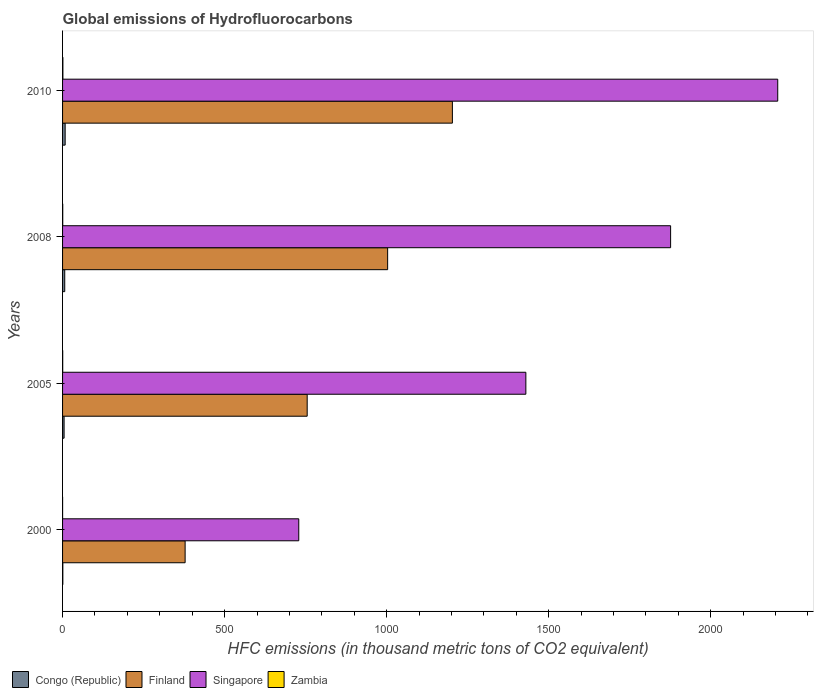How many different coloured bars are there?
Keep it short and to the point. 4. How many groups of bars are there?
Your answer should be very brief. 4. How many bars are there on the 2nd tick from the top?
Keep it short and to the point. 4. How many bars are there on the 1st tick from the bottom?
Your response must be concise. 4. What is the global emissions of Hydrofluorocarbons in Singapore in 2008?
Give a very brief answer. 1876.4. Across all years, what is the maximum global emissions of Hydrofluorocarbons in Singapore?
Keep it short and to the point. 2207. In which year was the global emissions of Hydrofluorocarbons in Zambia maximum?
Provide a short and direct response. 2010. What is the total global emissions of Hydrofluorocarbons in Singapore in the graph?
Your answer should be very brief. 6242. What is the difference between the global emissions of Hydrofluorocarbons in Singapore in 2008 and that in 2010?
Provide a short and direct response. -330.6. What is the difference between the global emissions of Hydrofluorocarbons in Congo (Republic) in 2000 and the global emissions of Hydrofluorocarbons in Zambia in 2008?
Your response must be concise. 0.3. What is the average global emissions of Hydrofluorocarbons in Zambia per year?
Your response must be concise. 0.5. In the year 2005, what is the difference between the global emissions of Hydrofluorocarbons in Finland and global emissions of Hydrofluorocarbons in Zambia?
Keep it short and to the point. 754.5. Is the difference between the global emissions of Hydrofluorocarbons in Finland in 2005 and 2010 greater than the difference between the global emissions of Hydrofluorocarbons in Zambia in 2005 and 2010?
Keep it short and to the point. No. What is the difference between the highest and the second highest global emissions of Hydrofluorocarbons in Congo (Republic)?
Ensure brevity in your answer.  1.3. What is the difference between the highest and the lowest global emissions of Hydrofluorocarbons in Finland?
Provide a short and direct response. 824.8. What does the 1st bar from the top in 2008 represents?
Keep it short and to the point. Zambia. What does the 4th bar from the bottom in 2000 represents?
Keep it short and to the point. Zambia. Are all the bars in the graph horizontal?
Make the answer very short. Yes. What is the difference between two consecutive major ticks on the X-axis?
Your answer should be very brief. 500. Does the graph contain grids?
Keep it short and to the point. No. Where does the legend appear in the graph?
Your answer should be compact. Bottom left. How many legend labels are there?
Offer a very short reply. 4. How are the legend labels stacked?
Make the answer very short. Horizontal. What is the title of the graph?
Provide a succinct answer. Global emissions of Hydrofluorocarbons. Does "Mozambique" appear as one of the legend labels in the graph?
Offer a terse response. No. What is the label or title of the X-axis?
Your answer should be compact. HFC emissions (in thousand metric tons of CO2 equivalent). What is the HFC emissions (in thousand metric tons of CO2 equivalent) in Finland in 2000?
Offer a very short reply. 378.2. What is the HFC emissions (in thousand metric tons of CO2 equivalent) in Singapore in 2000?
Keep it short and to the point. 728.9. What is the HFC emissions (in thousand metric tons of CO2 equivalent) of Zambia in 2000?
Your answer should be compact. 0.1. What is the HFC emissions (in thousand metric tons of CO2 equivalent) of Finland in 2005?
Give a very brief answer. 754.9. What is the HFC emissions (in thousand metric tons of CO2 equivalent) of Singapore in 2005?
Your answer should be very brief. 1429.7. What is the HFC emissions (in thousand metric tons of CO2 equivalent) in Finland in 2008?
Give a very brief answer. 1003.2. What is the HFC emissions (in thousand metric tons of CO2 equivalent) in Singapore in 2008?
Give a very brief answer. 1876.4. What is the HFC emissions (in thousand metric tons of CO2 equivalent) of Finland in 2010?
Make the answer very short. 1203. What is the HFC emissions (in thousand metric tons of CO2 equivalent) in Singapore in 2010?
Offer a very short reply. 2207. What is the HFC emissions (in thousand metric tons of CO2 equivalent) of Zambia in 2010?
Your response must be concise. 1. Across all years, what is the maximum HFC emissions (in thousand metric tons of CO2 equivalent) in Congo (Republic)?
Provide a succinct answer. 8. Across all years, what is the maximum HFC emissions (in thousand metric tons of CO2 equivalent) of Finland?
Your response must be concise. 1203. Across all years, what is the maximum HFC emissions (in thousand metric tons of CO2 equivalent) of Singapore?
Provide a short and direct response. 2207. Across all years, what is the maximum HFC emissions (in thousand metric tons of CO2 equivalent) in Zambia?
Your answer should be compact. 1. Across all years, what is the minimum HFC emissions (in thousand metric tons of CO2 equivalent) of Finland?
Provide a short and direct response. 378.2. Across all years, what is the minimum HFC emissions (in thousand metric tons of CO2 equivalent) in Singapore?
Your answer should be very brief. 728.9. What is the total HFC emissions (in thousand metric tons of CO2 equivalent) of Congo (Republic) in the graph?
Ensure brevity in your answer.  20.2. What is the total HFC emissions (in thousand metric tons of CO2 equivalent) of Finland in the graph?
Ensure brevity in your answer.  3339.3. What is the total HFC emissions (in thousand metric tons of CO2 equivalent) of Singapore in the graph?
Your answer should be compact. 6242. What is the total HFC emissions (in thousand metric tons of CO2 equivalent) of Zambia in the graph?
Keep it short and to the point. 2. What is the difference between the HFC emissions (in thousand metric tons of CO2 equivalent) in Congo (Republic) in 2000 and that in 2005?
Offer a terse response. -3.9. What is the difference between the HFC emissions (in thousand metric tons of CO2 equivalent) in Finland in 2000 and that in 2005?
Offer a terse response. -376.7. What is the difference between the HFC emissions (in thousand metric tons of CO2 equivalent) of Singapore in 2000 and that in 2005?
Your answer should be very brief. -700.8. What is the difference between the HFC emissions (in thousand metric tons of CO2 equivalent) in Congo (Republic) in 2000 and that in 2008?
Ensure brevity in your answer.  -5.9. What is the difference between the HFC emissions (in thousand metric tons of CO2 equivalent) of Finland in 2000 and that in 2008?
Make the answer very short. -625. What is the difference between the HFC emissions (in thousand metric tons of CO2 equivalent) of Singapore in 2000 and that in 2008?
Ensure brevity in your answer.  -1147.5. What is the difference between the HFC emissions (in thousand metric tons of CO2 equivalent) of Zambia in 2000 and that in 2008?
Provide a short and direct response. -0.4. What is the difference between the HFC emissions (in thousand metric tons of CO2 equivalent) in Finland in 2000 and that in 2010?
Make the answer very short. -824.8. What is the difference between the HFC emissions (in thousand metric tons of CO2 equivalent) of Singapore in 2000 and that in 2010?
Your answer should be very brief. -1478.1. What is the difference between the HFC emissions (in thousand metric tons of CO2 equivalent) in Zambia in 2000 and that in 2010?
Provide a succinct answer. -0.9. What is the difference between the HFC emissions (in thousand metric tons of CO2 equivalent) of Finland in 2005 and that in 2008?
Your answer should be compact. -248.3. What is the difference between the HFC emissions (in thousand metric tons of CO2 equivalent) in Singapore in 2005 and that in 2008?
Provide a succinct answer. -446.7. What is the difference between the HFC emissions (in thousand metric tons of CO2 equivalent) in Zambia in 2005 and that in 2008?
Give a very brief answer. -0.1. What is the difference between the HFC emissions (in thousand metric tons of CO2 equivalent) of Finland in 2005 and that in 2010?
Give a very brief answer. -448.1. What is the difference between the HFC emissions (in thousand metric tons of CO2 equivalent) in Singapore in 2005 and that in 2010?
Provide a short and direct response. -777.3. What is the difference between the HFC emissions (in thousand metric tons of CO2 equivalent) in Congo (Republic) in 2008 and that in 2010?
Your response must be concise. -1.3. What is the difference between the HFC emissions (in thousand metric tons of CO2 equivalent) of Finland in 2008 and that in 2010?
Provide a succinct answer. -199.8. What is the difference between the HFC emissions (in thousand metric tons of CO2 equivalent) in Singapore in 2008 and that in 2010?
Give a very brief answer. -330.6. What is the difference between the HFC emissions (in thousand metric tons of CO2 equivalent) in Congo (Republic) in 2000 and the HFC emissions (in thousand metric tons of CO2 equivalent) in Finland in 2005?
Provide a short and direct response. -754.1. What is the difference between the HFC emissions (in thousand metric tons of CO2 equivalent) of Congo (Republic) in 2000 and the HFC emissions (in thousand metric tons of CO2 equivalent) of Singapore in 2005?
Ensure brevity in your answer.  -1428.9. What is the difference between the HFC emissions (in thousand metric tons of CO2 equivalent) of Finland in 2000 and the HFC emissions (in thousand metric tons of CO2 equivalent) of Singapore in 2005?
Give a very brief answer. -1051.5. What is the difference between the HFC emissions (in thousand metric tons of CO2 equivalent) in Finland in 2000 and the HFC emissions (in thousand metric tons of CO2 equivalent) in Zambia in 2005?
Offer a very short reply. 377.8. What is the difference between the HFC emissions (in thousand metric tons of CO2 equivalent) of Singapore in 2000 and the HFC emissions (in thousand metric tons of CO2 equivalent) of Zambia in 2005?
Provide a succinct answer. 728.5. What is the difference between the HFC emissions (in thousand metric tons of CO2 equivalent) of Congo (Republic) in 2000 and the HFC emissions (in thousand metric tons of CO2 equivalent) of Finland in 2008?
Offer a very short reply. -1002.4. What is the difference between the HFC emissions (in thousand metric tons of CO2 equivalent) of Congo (Republic) in 2000 and the HFC emissions (in thousand metric tons of CO2 equivalent) of Singapore in 2008?
Offer a very short reply. -1875.6. What is the difference between the HFC emissions (in thousand metric tons of CO2 equivalent) in Finland in 2000 and the HFC emissions (in thousand metric tons of CO2 equivalent) in Singapore in 2008?
Offer a terse response. -1498.2. What is the difference between the HFC emissions (in thousand metric tons of CO2 equivalent) in Finland in 2000 and the HFC emissions (in thousand metric tons of CO2 equivalent) in Zambia in 2008?
Provide a short and direct response. 377.7. What is the difference between the HFC emissions (in thousand metric tons of CO2 equivalent) in Singapore in 2000 and the HFC emissions (in thousand metric tons of CO2 equivalent) in Zambia in 2008?
Make the answer very short. 728.4. What is the difference between the HFC emissions (in thousand metric tons of CO2 equivalent) in Congo (Republic) in 2000 and the HFC emissions (in thousand metric tons of CO2 equivalent) in Finland in 2010?
Make the answer very short. -1202.2. What is the difference between the HFC emissions (in thousand metric tons of CO2 equivalent) in Congo (Republic) in 2000 and the HFC emissions (in thousand metric tons of CO2 equivalent) in Singapore in 2010?
Make the answer very short. -2206.2. What is the difference between the HFC emissions (in thousand metric tons of CO2 equivalent) of Finland in 2000 and the HFC emissions (in thousand metric tons of CO2 equivalent) of Singapore in 2010?
Offer a terse response. -1828.8. What is the difference between the HFC emissions (in thousand metric tons of CO2 equivalent) in Finland in 2000 and the HFC emissions (in thousand metric tons of CO2 equivalent) in Zambia in 2010?
Offer a terse response. 377.2. What is the difference between the HFC emissions (in thousand metric tons of CO2 equivalent) in Singapore in 2000 and the HFC emissions (in thousand metric tons of CO2 equivalent) in Zambia in 2010?
Your answer should be compact. 727.9. What is the difference between the HFC emissions (in thousand metric tons of CO2 equivalent) of Congo (Republic) in 2005 and the HFC emissions (in thousand metric tons of CO2 equivalent) of Finland in 2008?
Ensure brevity in your answer.  -998.5. What is the difference between the HFC emissions (in thousand metric tons of CO2 equivalent) in Congo (Republic) in 2005 and the HFC emissions (in thousand metric tons of CO2 equivalent) in Singapore in 2008?
Provide a short and direct response. -1871.7. What is the difference between the HFC emissions (in thousand metric tons of CO2 equivalent) in Finland in 2005 and the HFC emissions (in thousand metric tons of CO2 equivalent) in Singapore in 2008?
Keep it short and to the point. -1121.5. What is the difference between the HFC emissions (in thousand metric tons of CO2 equivalent) of Finland in 2005 and the HFC emissions (in thousand metric tons of CO2 equivalent) of Zambia in 2008?
Give a very brief answer. 754.4. What is the difference between the HFC emissions (in thousand metric tons of CO2 equivalent) of Singapore in 2005 and the HFC emissions (in thousand metric tons of CO2 equivalent) of Zambia in 2008?
Offer a very short reply. 1429.2. What is the difference between the HFC emissions (in thousand metric tons of CO2 equivalent) of Congo (Republic) in 2005 and the HFC emissions (in thousand metric tons of CO2 equivalent) of Finland in 2010?
Keep it short and to the point. -1198.3. What is the difference between the HFC emissions (in thousand metric tons of CO2 equivalent) of Congo (Republic) in 2005 and the HFC emissions (in thousand metric tons of CO2 equivalent) of Singapore in 2010?
Your answer should be compact. -2202.3. What is the difference between the HFC emissions (in thousand metric tons of CO2 equivalent) of Congo (Republic) in 2005 and the HFC emissions (in thousand metric tons of CO2 equivalent) of Zambia in 2010?
Offer a very short reply. 3.7. What is the difference between the HFC emissions (in thousand metric tons of CO2 equivalent) of Finland in 2005 and the HFC emissions (in thousand metric tons of CO2 equivalent) of Singapore in 2010?
Keep it short and to the point. -1452.1. What is the difference between the HFC emissions (in thousand metric tons of CO2 equivalent) in Finland in 2005 and the HFC emissions (in thousand metric tons of CO2 equivalent) in Zambia in 2010?
Provide a succinct answer. 753.9. What is the difference between the HFC emissions (in thousand metric tons of CO2 equivalent) in Singapore in 2005 and the HFC emissions (in thousand metric tons of CO2 equivalent) in Zambia in 2010?
Keep it short and to the point. 1428.7. What is the difference between the HFC emissions (in thousand metric tons of CO2 equivalent) of Congo (Republic) in 2008 and the HFC emissions (in thousand metric tons of CO2 equivalent) of Finland in 2010?
Your answer should be very brief. -1196.3. What is the difference between the HFC emissions (in thousand metric tons of CO2 equivalent) in Congo (Republic) in 2008 and the HFC emissions (in thousand metric tons of CO2 equivalent) in Singapore in 2010?
Offer a very short reply. -2200.3. What is the difference between the HFC emissions (in thousand metric tons of CO2 equivalent) in Congo (Republic) in 2008 and the HFC emissions (in thousand metric tons of CO2 equivalent) in Zambia in 2010?
Keep it short and to the point. 5.7. What is the difference between the HFC emissions (in thousand metric tons of CO2 equivalent) of Finland in 2008 and the HFC emissions (in thousand metric tons of CO2 equivalent) of Singapore in 2010?
Your response must be concise. -1203.8. What is the difference between the HFC emissions (in thousand metric tons of CO2 equivalent) of Finland in 2008 and the HFC emissions (in thousand metric tons of CO2 equivalent) of Zambia in 2010?
Provide a short and direct response. 1002.2. What is the difference between the HFC emissions (in thousand metric tons of CO2 equivalent) in Singapore in 2008 and the HFC emissions (in thousand metric tons of CO2 equivalent) in Zambia in 2010?
Provide a short and direct response. 1875.4. What is the average HFC emissions (in thousand metric tons of CO2 equivalent) in Congo (Republic) per year?
Make the answer very short. 5.05. What is the average HFC emissions (in thousand metric tons of CO2 equivalent) in Finland per year?
Your answer should be very brief. 834.83. What is the average HFC emissions (in thousand metric tons of CO2 equivalent) of Singapore per year?
Make the answer very short. 1560.5. What is the average HFC emissions (in thousand metric tons of CO2 equivalent) of Zambia per year?
Provide a short and direct response. 0.5. In the year 2000, what is the difference between the HFC emissions (in thousand metric tons of CO2 equivalent) of Congo (Republic) and HFC emissions (in thousand metric tons of CO2 equivalent) of Finland?
Your answer should be compact. -377.4. In the year 2000, what is the difference between the HFC emissions (in thousand metric tons of CO2 equivalent) of Congo (Republic) and HFC emissions (in thousand metric tons of CO2 equivalent) of Singapore?
Provide a succinct answer. -728.1. In the year 2000, what is the difference between the HFC emissions (in thousand metric tons of CO2 equivalent) of Finland and HFC emissions (in thousand metric tons of CO2 equivalent) of Singapore?
Provide a short and direct response. -350.7. In the year 2000, what is the difference between the HFC emissions (in thousand metric tons of CO2 equivalent) of Finland and HFC emissions (in thousand metric tons of CO2 equivalent) of Zambia?
Give a very brief answer. 378.1. In the year 2000, what is the difference between the HFC emissions (in thousand metric tons of CO2 equivalent) in Singapore and HFC emissions (in thousand metric tons of CO2 equivalent) in Zambia?
Offer a very short reply. 728.8. In the year 2005, what is the difference between the HFC emissions (in thousand metric tons of CO2 equivalent) of Congo (Republic) and HFC emissions (in thousand metric tons of CO2 equivalent) of Finland?
Keep it short and to the point. -750.2. In the year 2005, what is the difference between the HFC emissions (in thousand metric tons of CO2 equivalent) of Congo (Republic) and HFC emissions (in thousand metric tons of CO2 equivalent) of Singapore?
Provide a succinct answer. -1425. In the year 2005, what is the difference between the HFC emissions (in thousand metric tons of CO2 equivalent) of Finland and HFC emissions (in thousand metric tons of CO2 equivalent) of Singapore?
Provide a succinct answer. -674.8. In the year 2005, what is the difference between the HFC emissions (in thousand metric tons of CO2 equivalent) in Finland and HFC emissions (in thousand metric tons of CO2 equivalent) in Zambia?
Make the answer very short. 754.5. In the year 2005, what is the difference between the HFC emissions (in thousand metric tons of CO2 equivalent) of Singapore and HFC emissions (in thousand metric tons of CO2 equivalent) of Zambia?
Provide a succinct answer. 1429.3. In the year 2008, what is the difference between the HFC emissions (in thousand metric tons of CO2 equivalent) of Congo (Republic) and HFC emissions (in thousand metric tons of CO2 equivalent) of Finland?
Provide a succinct answer. -996.5. In the year 2008, what is the difference between the HFC emissions (in thousand metric tons of CO2 equivalent) of Congo (Republic) and HFC emissions (in thousand metric tons of CO2 equivalent) of Singapore?
Make the answer very short. -1869.7. In the year 2008, what is the difference between the HFC emissions (in thousand metric tons of CO2 equivalent) in Finland and HFC emissions (in thousand metric tons of CO2 equivalent) in Singapore?
Give a very brief answer. -873.2. In the year 2008, what is the difference between the HFC emissions (in thousand metric tons of CO2 equivalent) in Finland and HFC emissions (in thousand metric tons of CO2 equivalent) in Zambia?
Offer a very short reply. 1002.7. In the year 2008, what is the difference between the HFC emissions (in thousand metric tons of CO2 equivalent) in Singapore and HFC emissions (in thousand metric tons of CO2 equivalent) in Zambia?
Your response must be concise. 1875.9. In the year 2010, what is the difference between the HFC emissions (in thousand metric tons of CO2 equivalent) of Congo (Republic) and HFC emissions (in thousand metric tons of CO2 equivalent) of Finland?
Your answer should be very brief. -1195. In the year 2010, what is the difference between the HFC emissions (in thousand metric tons of CO2 equivalent) in Congo (Republic) and HFC emissions (in thousand metric tons of CO2 equivalent) in Singapore?
Your answer should be compact. -2199. In the year 2010, what is the difference between the HFC emissions (in thousand metric tons of CO2 equivalent) in Congo (Republic) and HFC emissions (in thousand metric tons of CO2 equivalent) in Zambia?
Offer a very short reply. 7. In the year 2010, what is the difference between the HFC emissions (in thousand metric tons of CO2 equivalent) of Finland and HFC emissions (in thousand metric tons of CO2 equivalent) of Singapore?
Ensure brevity in your answer.  -1004. In the year 2010, what is the difference between the HFC emissions (in thousand metric tons of CO2 equivalent) of Finland and HFC emissions (in thousand metric tons of CO2 equivalent) of Zambia?
Provide a short and direct response. 1202. In the year 2010, what is the difference between the HFC emissions (in thousand metric tons of CO2 equivalent) in Singapore and HFC emissions (in thousand metric tons of CO2 equivalent) in Zambia?
Your response must be concise. 2206. What is the ratio of the HFC emissions (in thousand metric tons of CO2 equivalent) of Congo (Republic) in 2000 to that in 2005?
Your answer should be compact. 0.17. What is the ratio of the HFC emissions (in thousand metric tons of CO2 equivalent) in Finland in 2000 to that in 2005?
Provide a short and direct response. 0.5. What is the ratio of the HFC emissions (in thousand metric tons of CO2 equivalent) of Singapore in 2000 to that in 2005?
Ensure brevity in your answer.  0.51. What is the ratio of the HFC emissions (in thousand metric tons of CO2 equivalent) of Zambia in 2000 to that in 2005?
Your answer should be very brief. 0.25. What is the ratio of the HFC emissions (in thousand metric tons of CO2 equivalent) of Congo (Republic) in 2000 to that in 2008?
Offer a terse response. 0.12. What is the ratio of the HFC emissions (in thousand metric tons of CO2 equivalent) in Finland in 2000 to that in 2008?
Your answer should be very brief. 0.38. What is the ratio of the HFC emissions (in thousand metric tons of CO2 equivalent) of Singapore in 2000 to that in 2008?
Offer a very short reply. 0.39. What is the ratio of the HFC emissions (in thousand metric tons of CO2 equivalent) in Zambia in 2000 to that in 2008?
Make the answer very short. 0.2. What is the ratio of the HFC emissions (in thousand metric tons of CO2 equivalent) of Finland in 2000 to that in 2010?
Provide a succinct answer. 0.31. What is the ratio of the HFC emissions (in thousand metric tons of CO2 equivalent) of Singapore in 2000 to that in 2010?
Your answer should be compact. 0.33. What is the ratio of the HFC emissions (in thousand metric tons of CO2 equivalent) of Congo (Republic) in 2005 to that in 2008?
Your response must be concise. 0.7. What is the ratio of the HFC emissions (in thousand metric tons of CO2 equivalent) of Finland in 2005 to that in 2008?
Ensure brevity in your answer.  0.75. What is the ratio of the HFC emissions (in thousand metric tons of CO2 equivalent) of Singapore in 2005 to that in 2008?
Offer a terse response. 0.76. What is the ratio of the HFC emissions (in thousand metric tons of CO2 equivalent) in Zambia in 2005 to that in 2008?
Your answer should be very brief. 0.8. What is the ratio of the HFC emissions (in thousand metric tons of CO2 equivalent) of Congo (Republic) in 2005 to that in 2010?
Ensure brevity in your answer.  0.59. What is the ratio of the HFC emissions (in thousand metric tons of CO2 equivalent) of Finland in 2005 to that in 2010?
Provide a succinct answer. 0.63. What is the ratio of the HFC emissions (in thousand metric tons of CO2 equivalent) in Singapore in 2005 to that in 2010?
Provide a short and direct response. 0.65. What is the ratio of the HFC emissions (in thousand metric tons of CO2 equivalent) of Congo (Republic) in 2008 to that in 2010?
Your answer should be compact. 0.84. What is the ratio of the HFC emissions (in thousand metric tons of CO2 equivalent) of Finland in 2008 to that in 2010?
Offer a very short reply. 0.83. What is the ratio of the HFC emissions (in thousand metric tons of CO2 equivalent) in Singapore in 2008 to that in 2010?
Your response must be concise. 0.85. What is the ratio of the HFC emissions (in thousand metric tons of CO2 equivalent) in Zambia in 2008 to that in 2010?
Keep it short and to the point. 0.5. What is the difference between the highest and the second highest HFC emissions (in thousand metric tons of CO2 equivalent) of Finland?
Provide a short and direct response. 199.8. What is the difference between the highest and the second highest HFC emissions (in thousand metric tons of CO2 equivalent) in Singapore?
Make the answer very short. 330.6. What is the difference between the highest and the second highest HFC emissions (in thousand metric tons of CO2 equivalent) in Zambia?
Offer a very short reply. 0.5. What is the difference between the highest and the lowest HFC emissions (in thousand metric tons of CO2 equivalent) of Congo (Republic)?
Offer a terse response. 7.2. What is the difference between the highest and the lowest HFC emissions (in thousand metric tons of CO2 equivalent) of Finland?
Your response must be concise. 824.8. What is the difference between the highest and the lowest HFC emissions (in thousand metric tons of CO2 equivalent) in Singapore?
Give a very brief answer. 1478.1. 